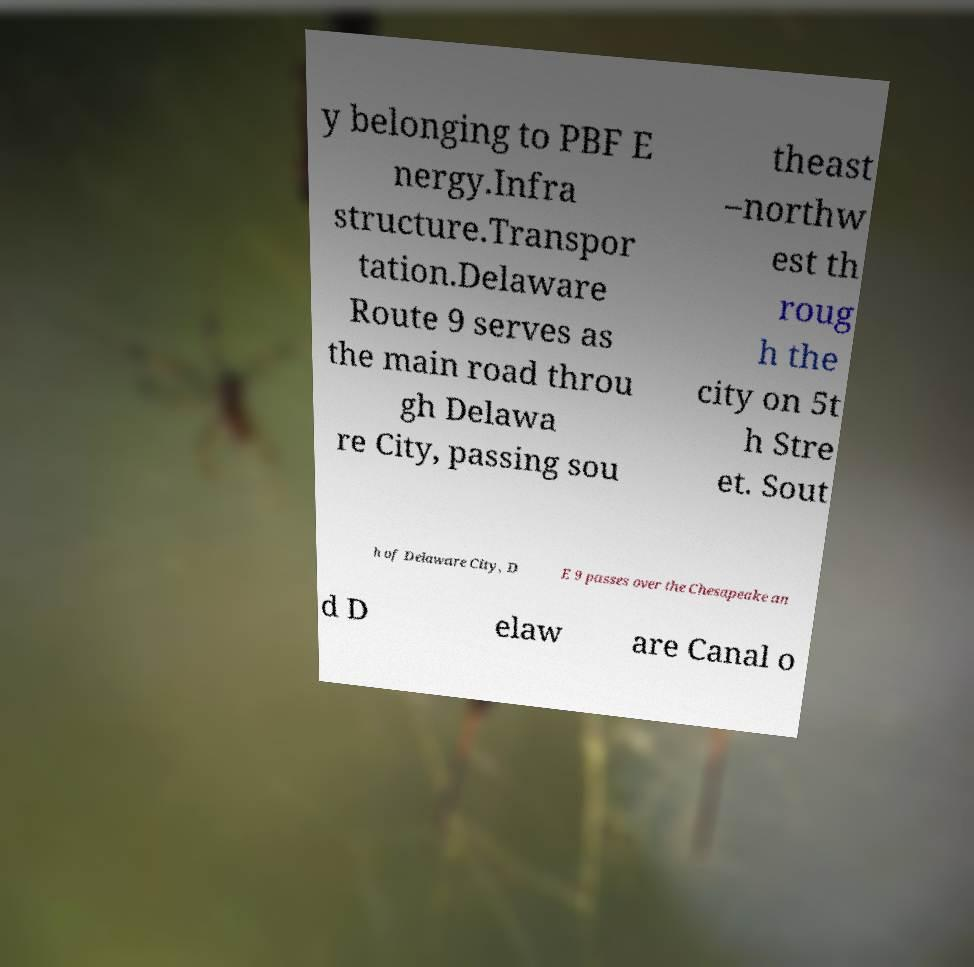I need the written content from this picture converted into text. Can you do that? y belonging to PBF E nergy.Infra structure.Transpor tation.Delaware Route 9 serves as the main road throu gh Delawa re City, passing sou theast –northw est th roug h the city on 5t h Stre et. Sout h of Delaware City, D E 9 passes over the Chesapeake an d D elaw are Canal o 